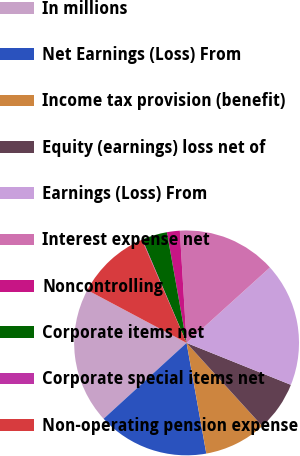Convert chart. <chart><loc_0><loc_0><loc_500><loc_500><pie_chart><fcel>In millions<fcel>Net Earnings (Loss) From<fcel>Income tax provision (benefit)<fcel>Equity (earnings) loss net of<fcel>Earnings (Loss) From<fcel>Interest expense net<fcel>Noncontrolling<fcel>Corporate items net<fcel>Corporate special items net<fcel>Non-operating pension expense<nl><fcel>19.57%<fcel>16.02%<fcel>8.94%<fcel>7.17%<fcel>17.79%<fcel>14.25%<fcel>1.85%<fcel>3.62%<fcel>0.08%<fcel>10.71%<nl></chart> 